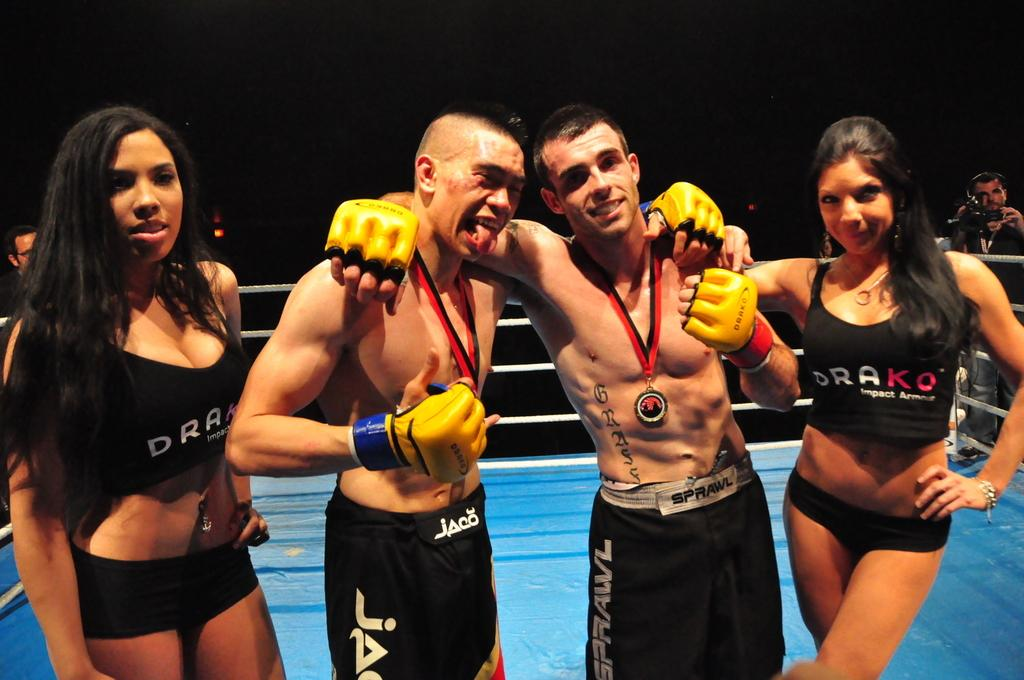What is the main setting of the image? There is a fighting ring in the image. How many people are inside the fighting ring? Four persons are present in the fighting ring. What type of activity are the two people in the ring engaged in? There are two boxing players in the ring. What is the role of the two girls on either side of the boxing players? The two girls are on either side of the boxing players, possibly as spectators or support. What type of church is visible in the background of the image? There is no church visible in the background of the image; it features a fighting ring with boxing players and spectators. What type of collar is being worn by the party guests in the image? There is no party or guests mentioned in the image, and therefore no collars can be observed. 